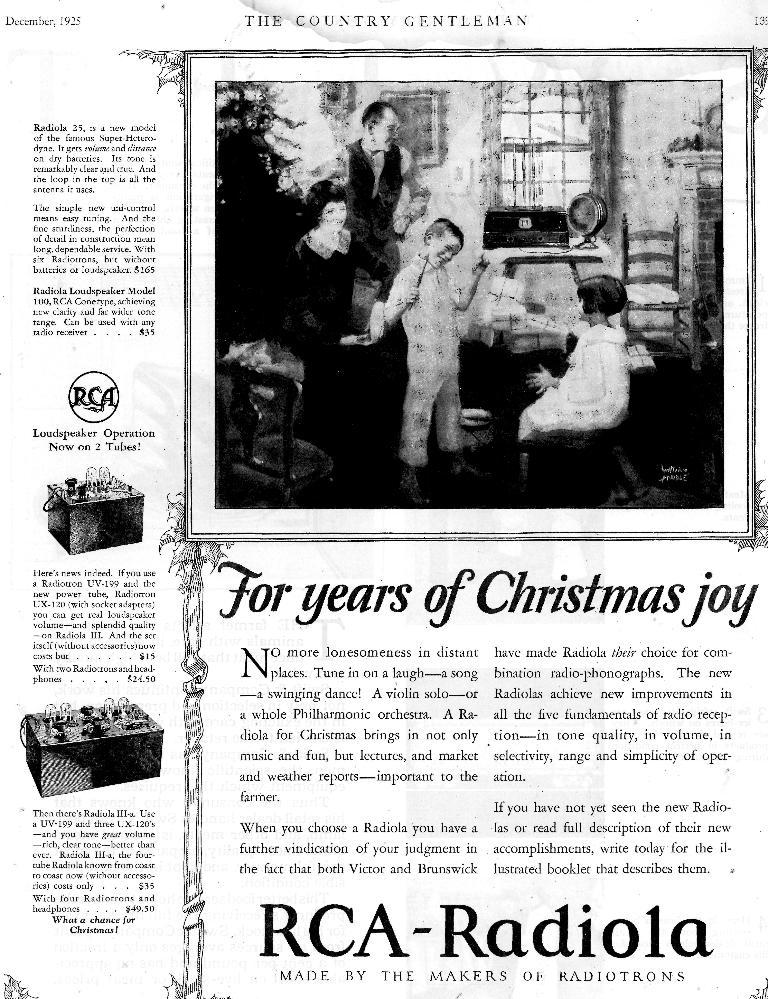What is the main object in the image? There is a newspaper in the image. What can be found on the newspaper? The newspaper has text on it. Are there any other items visible in the image? Yes, there is a family photo in the image. What type of meat is being sold at the market in the image? There is no market or meat present in the image; it features a newspaper and a family photo. How many hens can be seen in the image? There are no hens present in the image. 